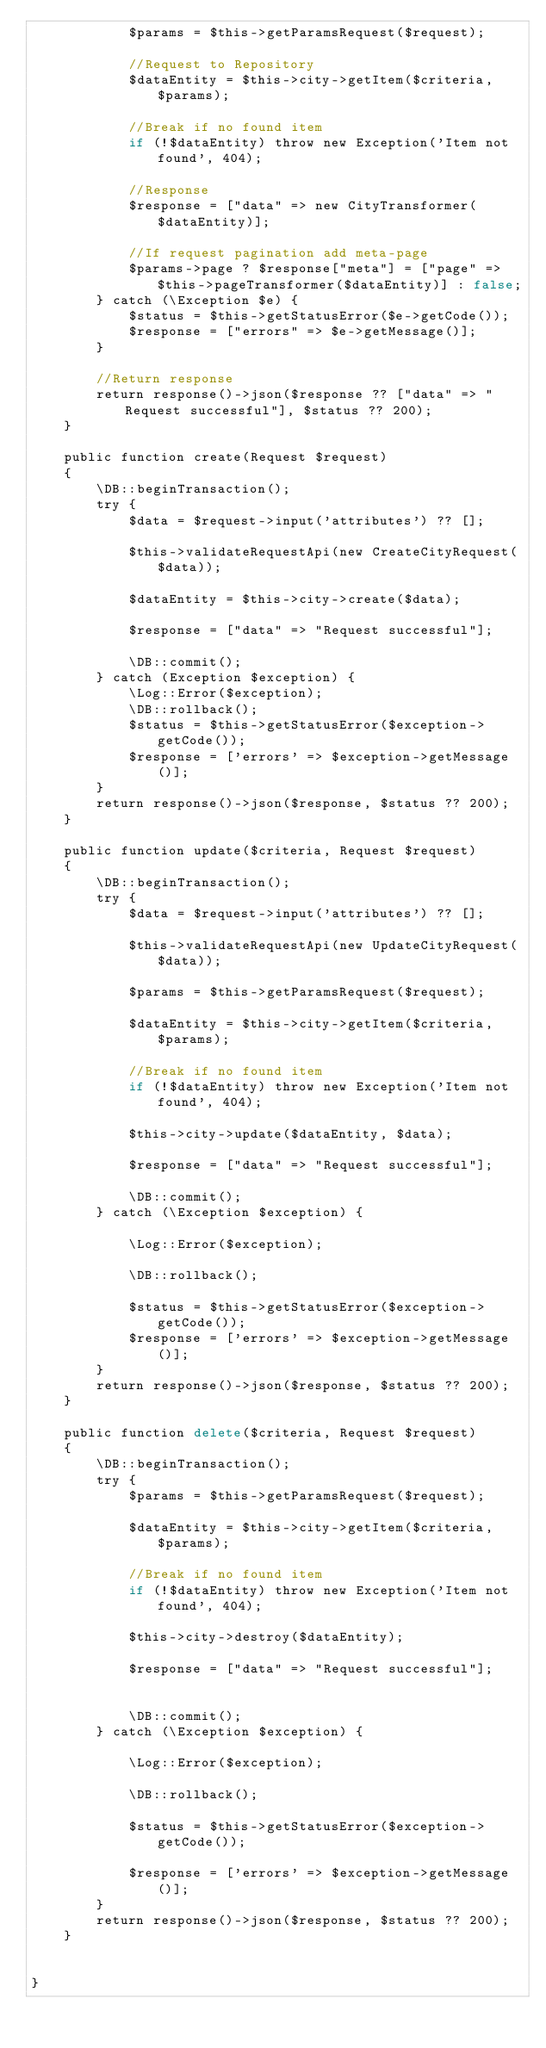Convert code to text. <code><loc_0><loc_0><loc_500><loc_500><_PHP_>            $params = $this->getParamsRequest($request);

            //Request to Repository
            $dataEntity = $this->city->getItem($criteria, $params);

            //Break if no found item
            if (!$dataEntity) throw new Exception('Item not found', 404);

            //Response
            $response = ["data" => new CityTransformer($dataEntity)];

            //If request pagination add meta-page
            $params->page ? $response["meta"] = ["page" => $this->pageTransformer($dataEntity)] : false;
        } catch (\Exception $e) {
            $status = $this->getStatusError($e->getCode());
            $response = ["errors" => $e->getMessage()];
        }

        //Return response
        return response()->json($response ?? ["data" => "Request successful"], $status ?? 200);
    }

    public function create(Request $request)
    {
        \DB::beginTransaction();
        try {
            $data = $request->input('attributes') ?? [];

            $this->validateRequestApi(new CreateCityRequest($data));

            $dataEntity = $this->city->create($data);

            $response = ["data" => "Request successful"];

            \DB::commit();
        } catch (Exception $exception) {
            \Log::Error($exception);
            \DB::rollback();
            $status = $this->getStatusError($exception->getCode());
            $response = ['errors' => $exception->getMessage()];
        }
        return response()->json($response, $status ?? 200);
    }

    public function update($criteria, Request $request)
    {
        \DB::beginTransaction();
        try {
            $data = $request->input('attributes') ?? [];

            $this->validateRequestApi(new UpdateCityRequest($data));

            $params = $this->getParamsRequest($request);

            $dataEntity = $this->city->getItem($criteria, $params);

            //Break if no found item
            if (!$dataEntity) throw new Exception('Item not found', 404);

            $this->city->update($dataEntity, $data);

            $response = ["data" => "Request successful"];

            \DB::commit();
        } catch (\Exception $exception) {

            \Log::Error($exception);

            \DB::rollback();

            $status = $this->getStatusError($exception->getCode());
            $response = ['errors' => $exception->getMessage()];
        }
        return response()->json($response, $status ?? 200);
    }

    public function delete($criteria, Request $request)
    {
        \DB::beginTransaction();
        try {
            $params = $this->getParamsRequest($request);

            $dataEntity = $this->city->getItem($criteria, $params);

            //Break if no found item
            if (!$dataEntity) throw new Exception('Item not found', 404);

            $this->city->destroy($dataEntity);

            $response = ["data" => "Request successful"];


            \DB::commit();
        } catch (\Exception $exception) {

            \Log::Error($exception);

            \DB::rollback();

            $status = $this->getStatusError($exception->getCode());

            $response = ['errors' => $exception->getMessage()];
        }
        return response()->json($response, $status ?? 200);
    }


}
</code> 